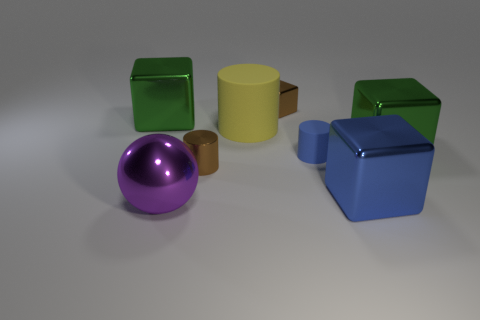Does the big sphere have the same material as the cylinder that is behind the small blue cylinder?
Make the answer very short. No. There is a green shiny object on the right side of the large block that is on the left side of the large matte cylinder; what is its shape?
Your answer should be very brief. Cube. The big thing that is left of the small brown cylinder and behind the large purple shiny ball has what shape?
Keep it short and to the point. Cube. How many things are large metal balls or large things that are to the left of the big blue cube?
Provide a succinct answer. 3. There is another yellow object that is the same shape as the tiny matte object; what material is it?
Keep it short and to the point. Rubber. There is a cylinder that is on the left side of the blue cylinder and behind the brown cylinder; what material is it?
Provide a short and direct response. Rubber. What number of other things have the same shape as the large matte object?
Your answer should be very brief. 2. What color is the tiny cube to the right of the big green cube behind the big cylinder?
Provide a succinct answer. Brown. Is the number of small brown shiny cubes to the left of the yellow thing the same as the number of blue metallic objects?
Make the answer very short. No. Is there a brown thing that has the same size as the blue matte object?
Ensure brevity in your answer.  Yes. 